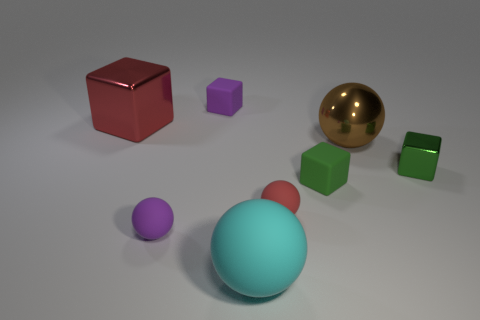What could be the purpose of arranging these objects in this specific layout? The arrangement of these objects could serve various purposes. It could be a display meant for aesthetic purposes, demonstrating a study on color contrast and composition. Alternatively, it might be a setup for a physics lesson about shapes, textures, and material properties. 